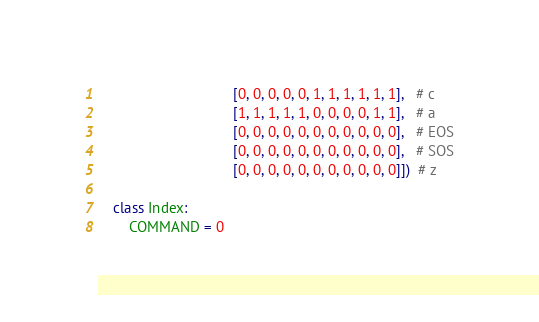Convert code to text. <code><loc_0><loc_0><loc_500><loc_500><_Python_>                                  [0, 0, 0, 0, 0, 1, 1, 1, 1, 1, 1],   # c
                                  [1, 1, 1, 1, 1, 0, 0, 0, 0, 1, 1],   # a
                                  [0, 0, 0, 0, 0, 0, 0, 0, 0, 0, 0],   # EOS
                                  [0, 0, 0, 0, 0, 0, 0, 0, 0, 0, 0],   # SOS
                                  [0, 0, 0, 0, 0, 0, 0, 0, 0, 0, 0]])  # z

    class Index:
        COMMAND = 0</code> 